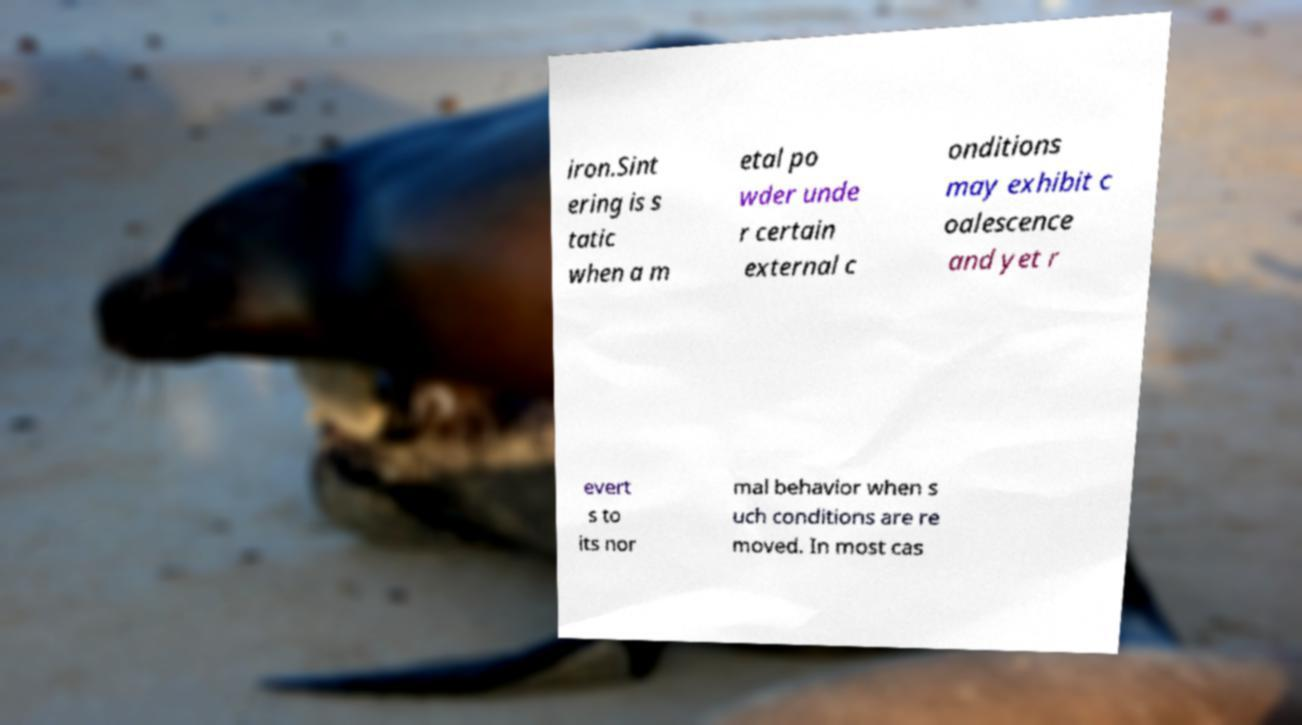Can you accurately transcribe the text from the provided image for me? iron.Sint ering is s tatic when a m etal po wder unde r certain external c onditions may exhibit c oalescence and yet r evert s to its nor mal behavior when s uch conditions are re moved. In most cas 